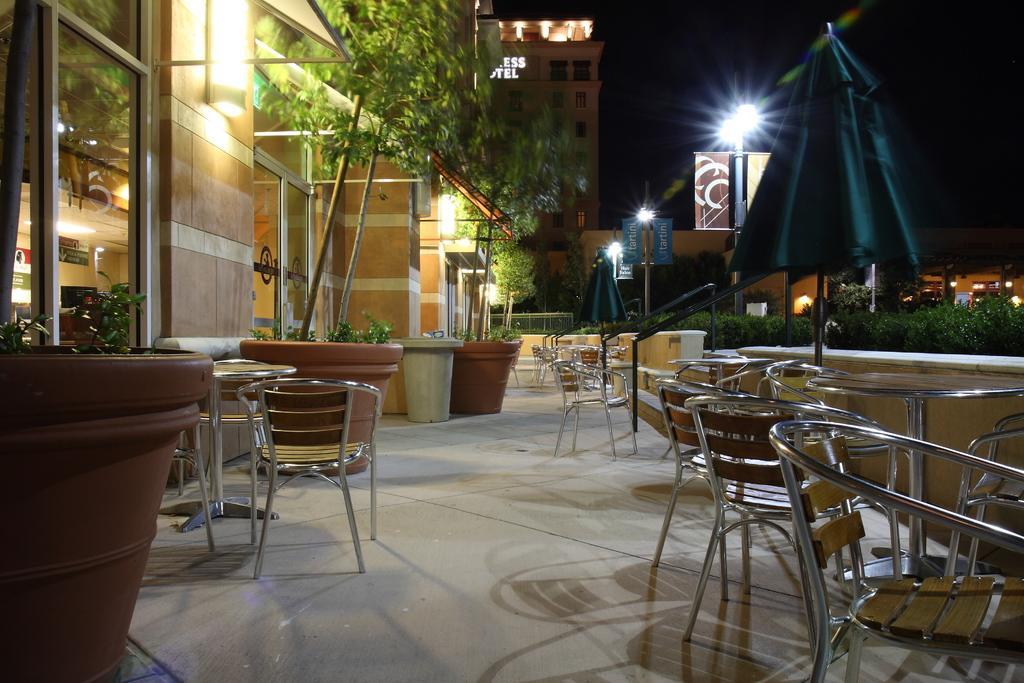Could you give a brief overview of what you see in this image? It is a outside view. So many tables and chairs are there. On left side, we can see some plants and pot. And cream color wall and glass windows. At the background, we can see building, skylights, banners. And here we can see umbrellas, some plants, house. 